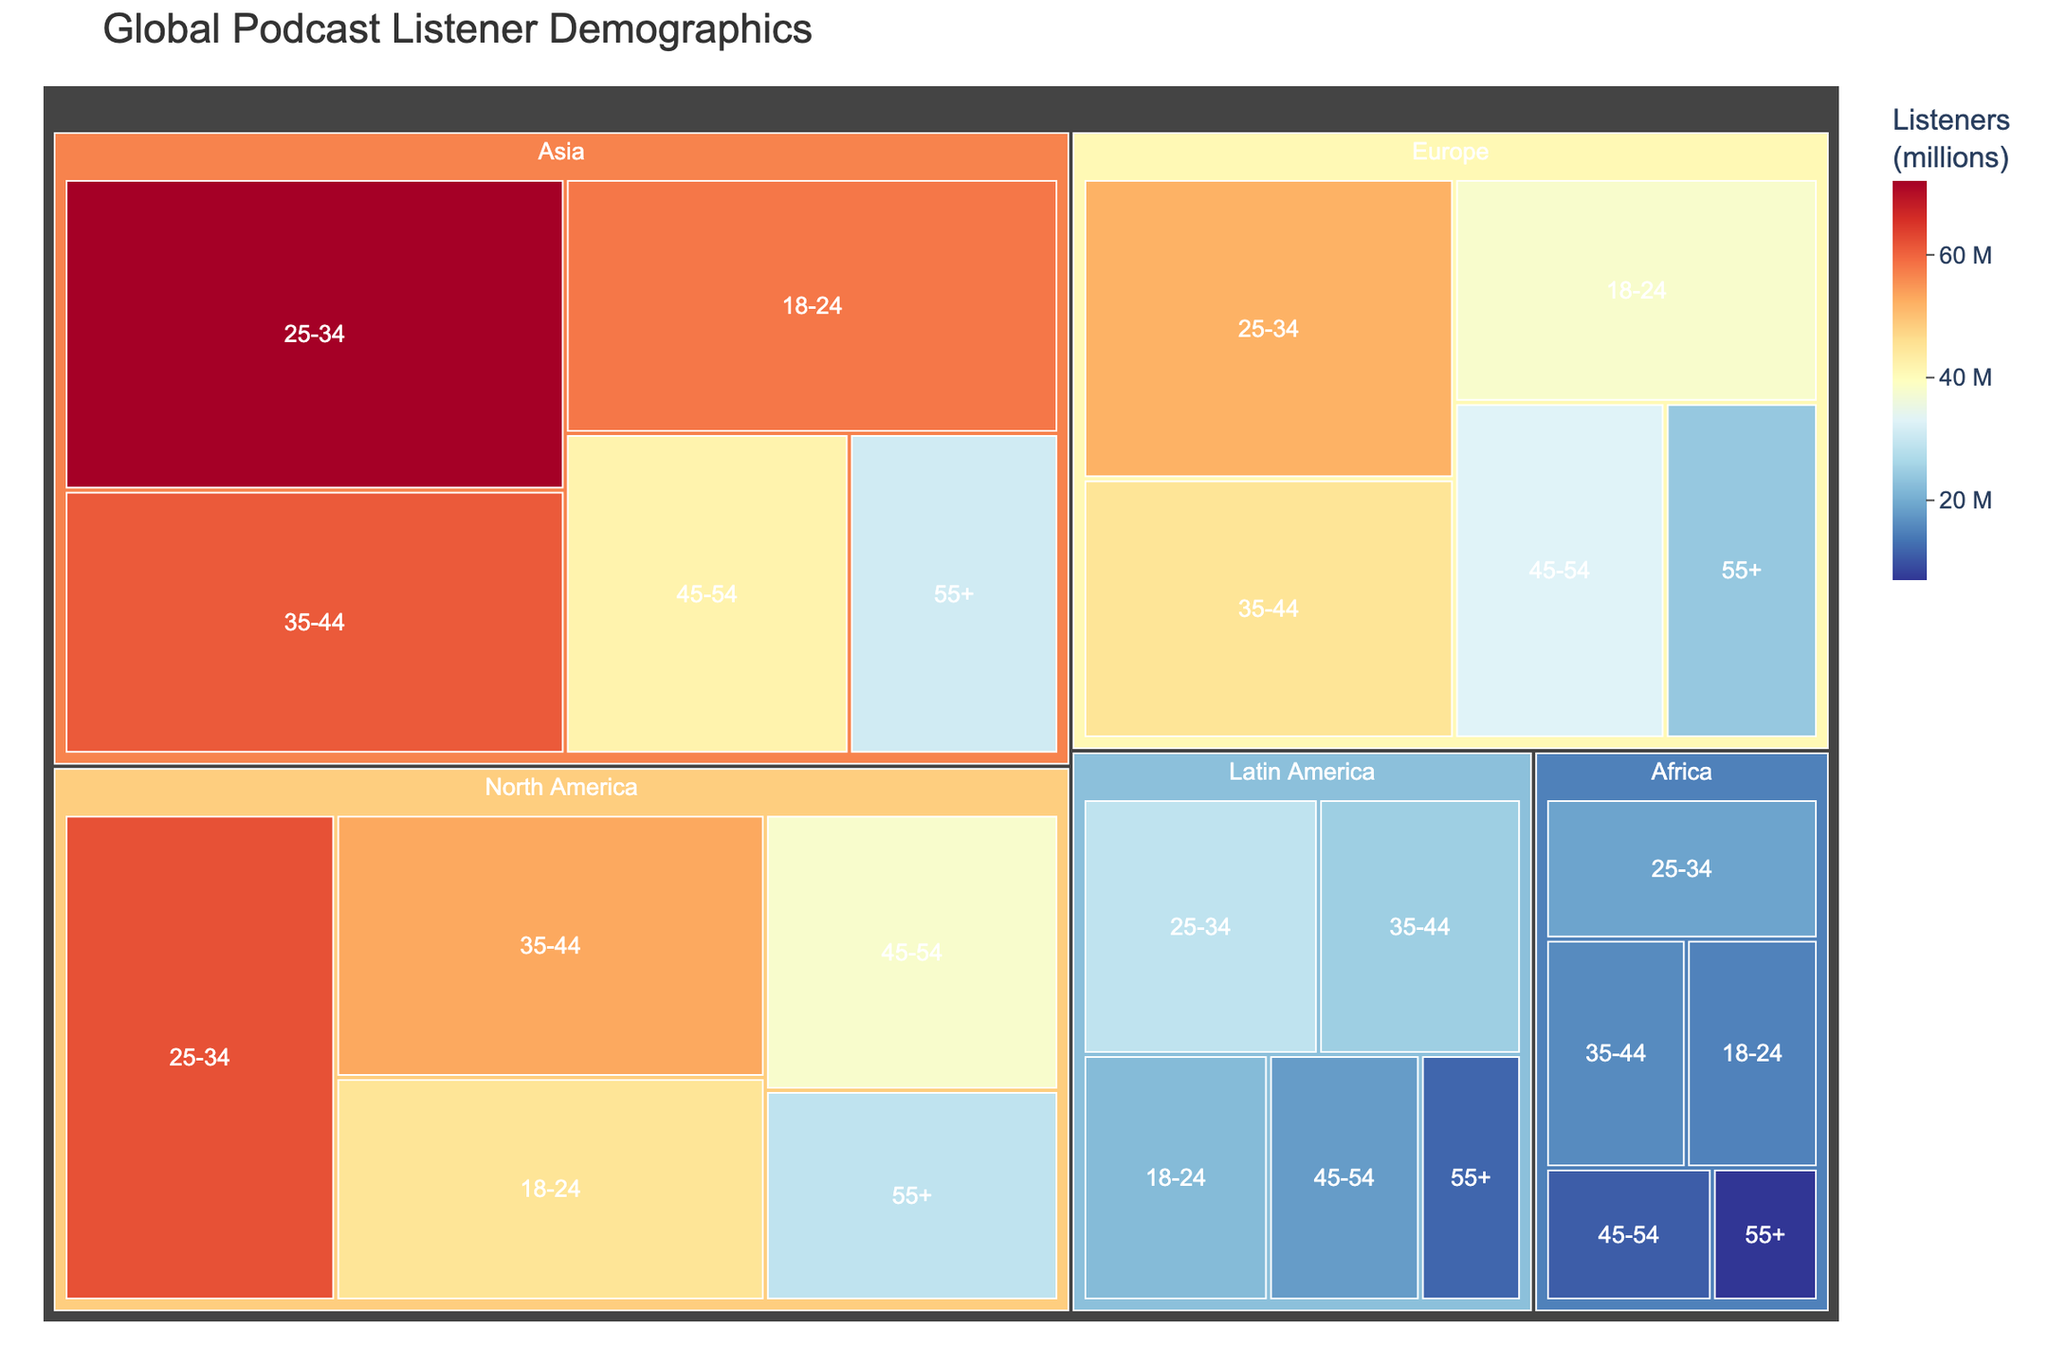What is the title of the treemap? The title of a treemap is usually displayed at the top of the figure.
Answer: Global Podcast Listener Demographics Which age group in North America has the highest number of listeners? Look for the section labeled "North America" and find the age group with the largest area and highest value.
Answer: 25-34 How many listeners are there in the 18-24 age group in Asia? Identify the "Asia" region in the treemap, then locate the 18-24 age group to read the value displayed.
Answer: 58 million Which region has the smallest number of listeners in the 55+ age group? Identify the 55+ age groups in all regions and compare their values to determine the smallest.
Answer: Africa What is the total number of listeners in the 35-44 age group across all regions? Sum the number of listeners for the 35-44 age group from all regions: 53 (North America) + 45 (Europe) + 61 (Asia) + 25 (Latin America) + 16 (Africa).
Answer: 200 million Which region has the most evenly distributed podcast listeners across all age groups? Compare the sizes of the segments for each age group within each region to judge the distribution pattern.
Answer: Europe What's the difference in the number of listeners between the 25-34 and the 45-54 age groups in Asia? Subtract the number of listeners in the 45-54 age group from that in the 25-34 age group in Asia: 72 - 42.
Answer: 30 million In which region is the age group 18-24 the smallest, and what is the number of listeners? Identify the 18-24 age groups across all regions and compare their values to find the smallest.
Answer: Africa, 15 million By how much does the number of listeners in the 25-34 age group in Europe exceed that in Latin America? Subtract the number of listeners in Latin America from that in Europe for the 25-34 age group: 52 - 29.
Answer: 23 million Which region has the largest overall number of podcast listeners aged 55+? Compare the total sizes of the 55+ segments in each region to determine the largest.
Answer: North America 